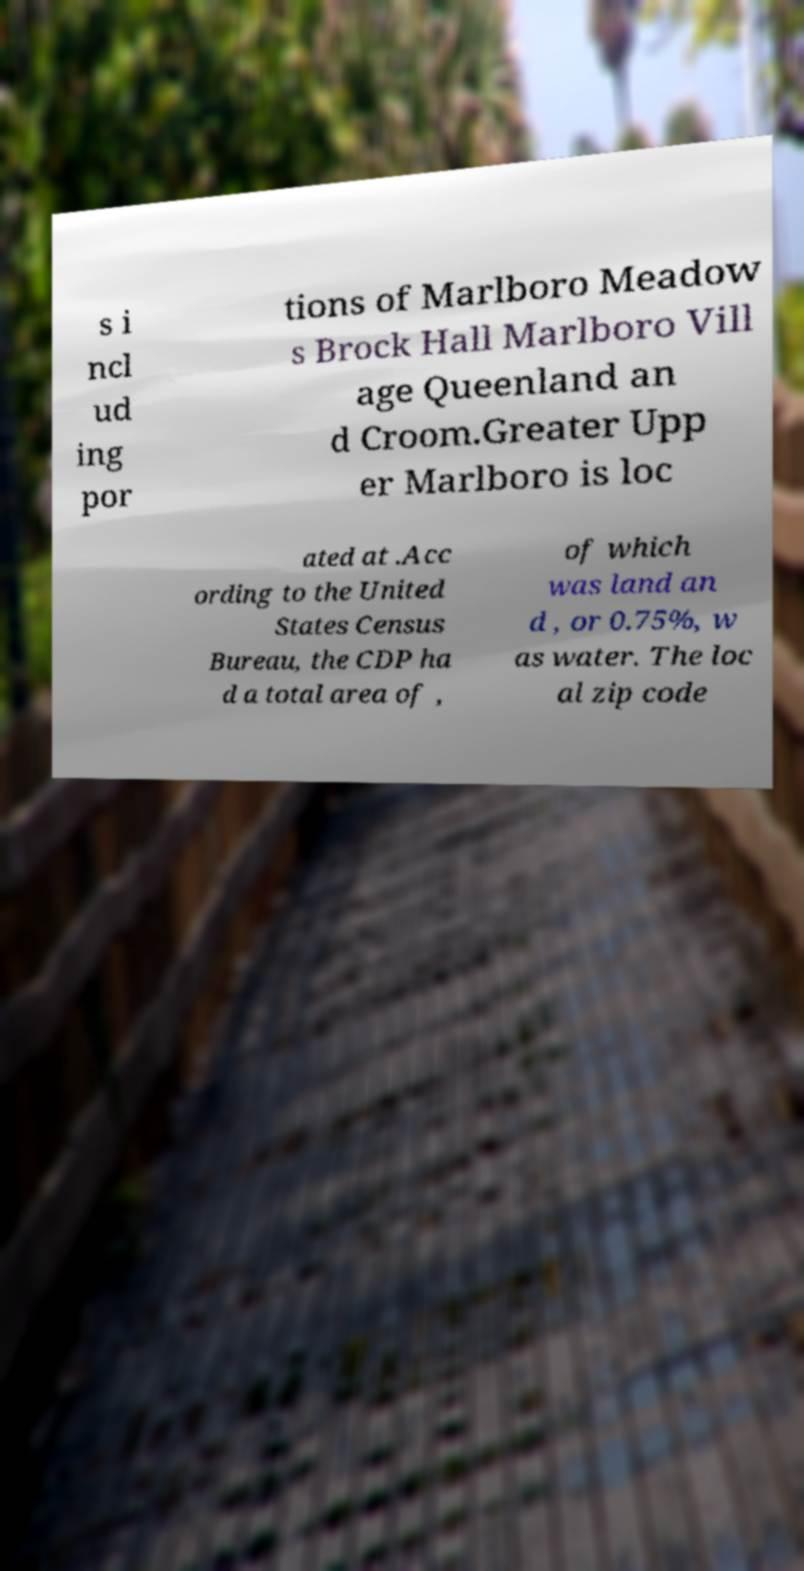Please read and relay the text visible in this image. What does it say? s i ncl ud ing por tions of Marlboro Meadow s Brock Hall Marlboro Vill age Queenland an d Croom.Greater Upp er Marlboro is loc ated at .Acc ording to the United States Census Bureau, the CDP ha d a total area of , of which was land an d , or 0.75%, w as water. The loc al zip code 